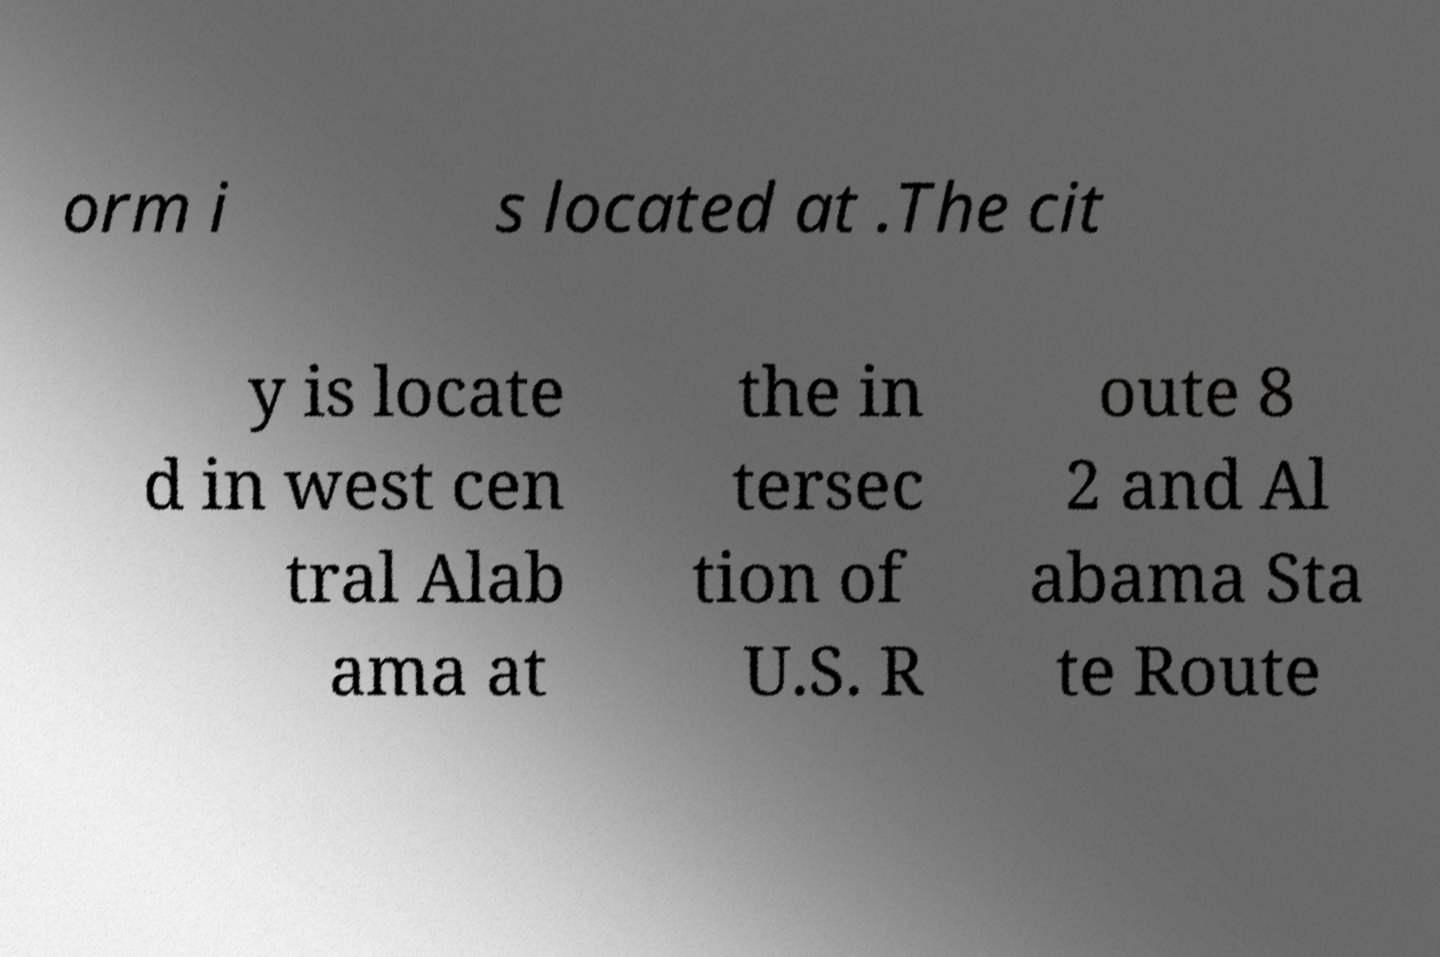I need the written content from this picture converted into text. Can you do that? orm i s located at .The cit y is locate d in west cen tral Alab ama at the in tersec tion of U.S. R oute 8 2 and Al abama Sta te Route 